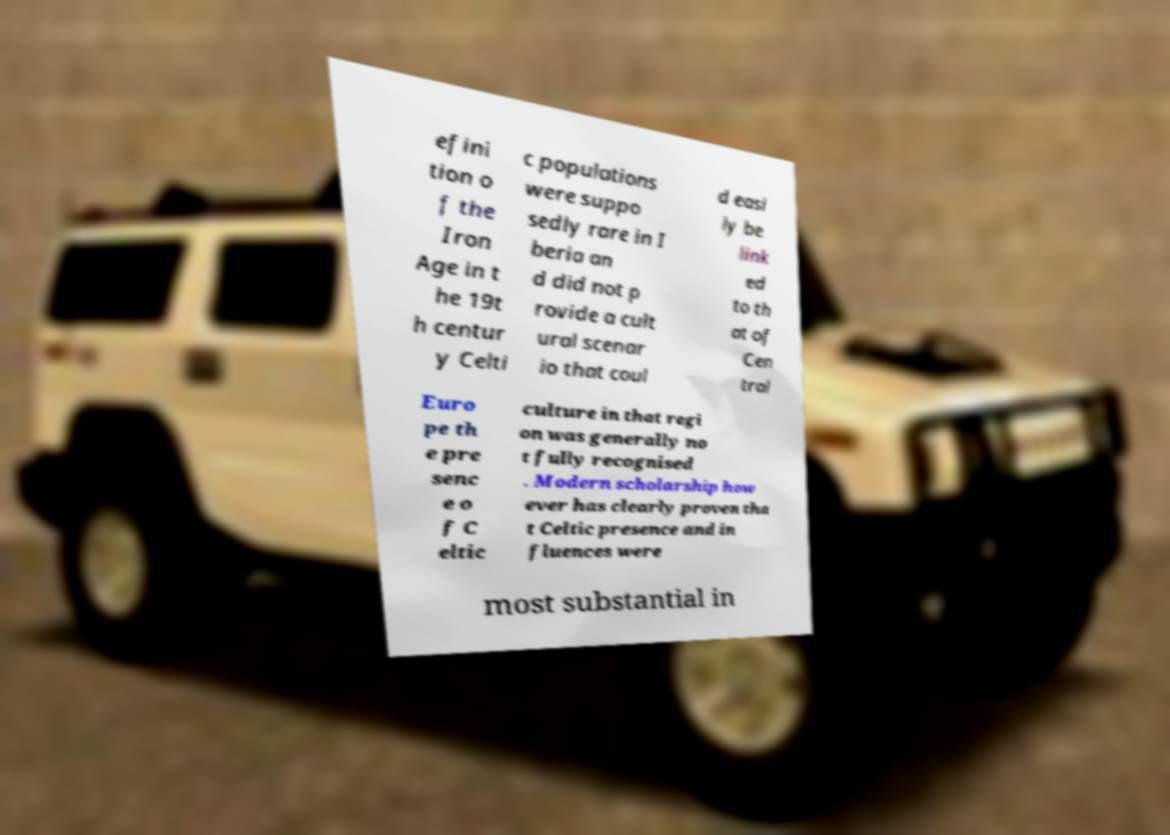What messages or text are displayed in this image? I need them in a readable, typed format. efini tion o f the Iron Age in t he 19t h centur y Celti c populations were suppo sedly rare in I beria an d did not p rovide a cult ural scenar io that coul d easi ly be link ed to th at of Cen tral Euro pe th e pre senc e o f C eltic culture in that regi on was generally no t fully recognised . Modern scholarship how ever has clearly proven tha t Celtic presence and in fluences were most substantial in 